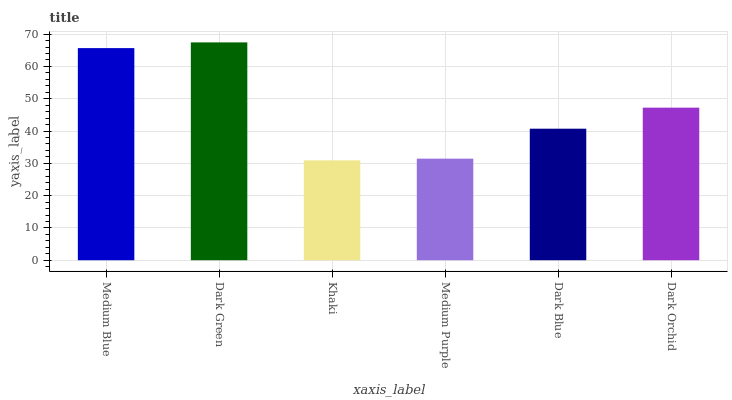Is Khaki the minimum?
Answer yes or no. Yes. Is Dark Green the maximum?
Answer yes or no. Yes. Is Dark Green the minimum?
Answer yes or no. No. Is Khaki the maximum?
Answer yes or no. No. Is Dark Green greater than Khaki?
Answer yes or no. Yes. Is Khaki less than Dark Green?
Answer yes or no. Yes. Is Khaki greater than Dark Green?
Answer yes or no. No. Is Dark Green less than Khaki?
Answer yes or no. No. Is Dark Orchid the high median?
Answer yes or no. Yes. Is Dark Blue the low median?
Answer yes or no. Yes. Is Dark Blue the high median?
Answer yes or no. No. Is Dark Green the low median?
Answer yes or no. No. 